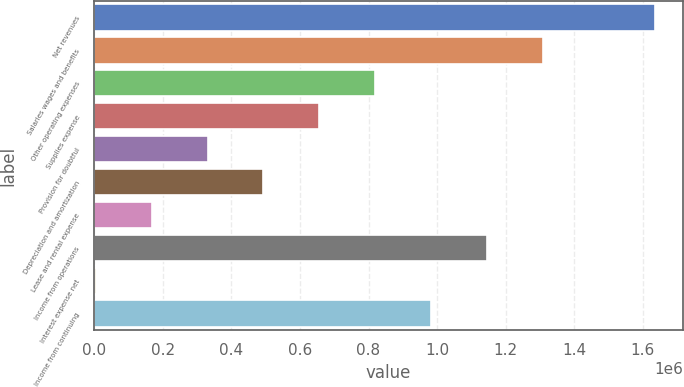Convert chart to OTSL. <chart><loc_0><loc_0><loc_500><loc_500><bar_chart><fcel>Net revenues<fcel>Salaries wages and benefits<fcel>Other operating expenses<fcel>Supplies expense<fcel>Provision for doubtful<fcel>Depreciation and amortization<fcel>Lease and rental expense<fcel>Income from operations<fcel>Interest expense net<fcel>Income from continuing<nl><fcel>1.63546e+06<fcel>1.30921e+06<fcel>819833<fcel>656709<fcel>330460<fcel>493584<fcel>167335<fcel>1.14608e+06<fcel>4211<fcel>982957<nl></chart> 